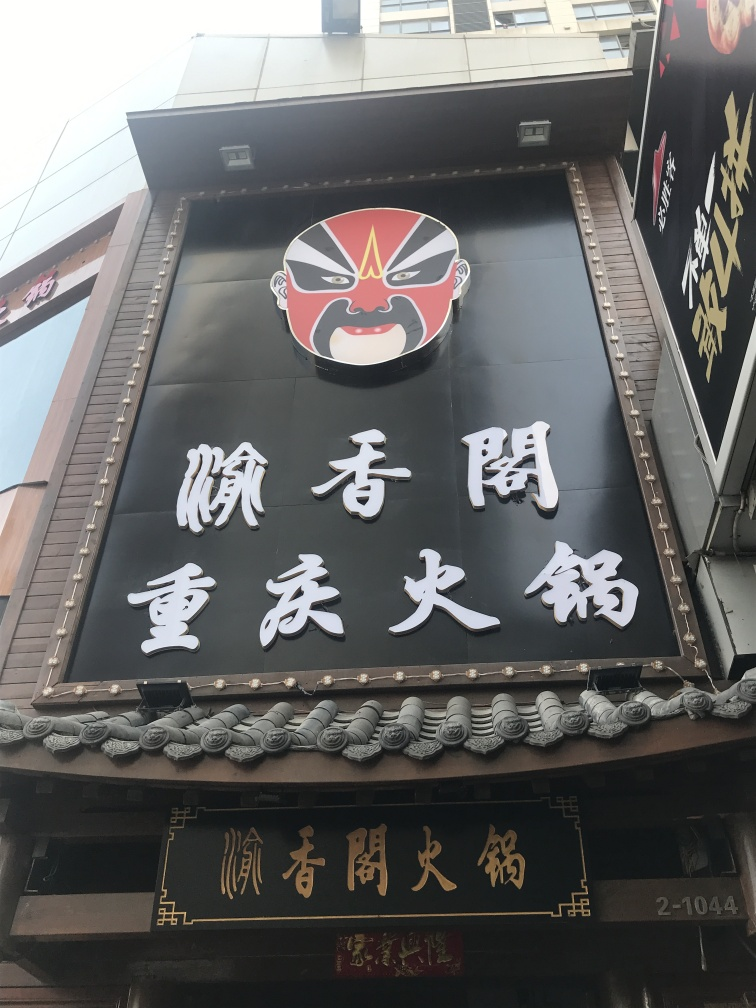What type of establishment does this sign belong to? The sign features stylistic elements and characters commonly associated with traditional Japanese culture, suggesting that this establishment could be a Japanese restaurant or performance venue, possibly offering a cultural experience like kabuki theatre. 